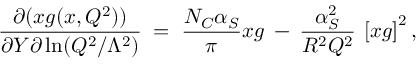Convert formula to latex. <formula><loc_0><loc_0><loc_500><loc_500>\frac { \partial ( x g ( x , Q ^ { 2 } ) ) } { \partial Y \partial \ln ( Q ^ { 2 } / \Lambda ^ { 2 } ) } \, = \, \frac { N _ { C } \alpha _ { S } } { \pi } x g \, - \, \frac { \alpha _ { S } ^ { 2 } } { R ^ { 2 } Q ^ { 2 } } \, \left [ x g \right ] ^ { 2 } ,</formula> 